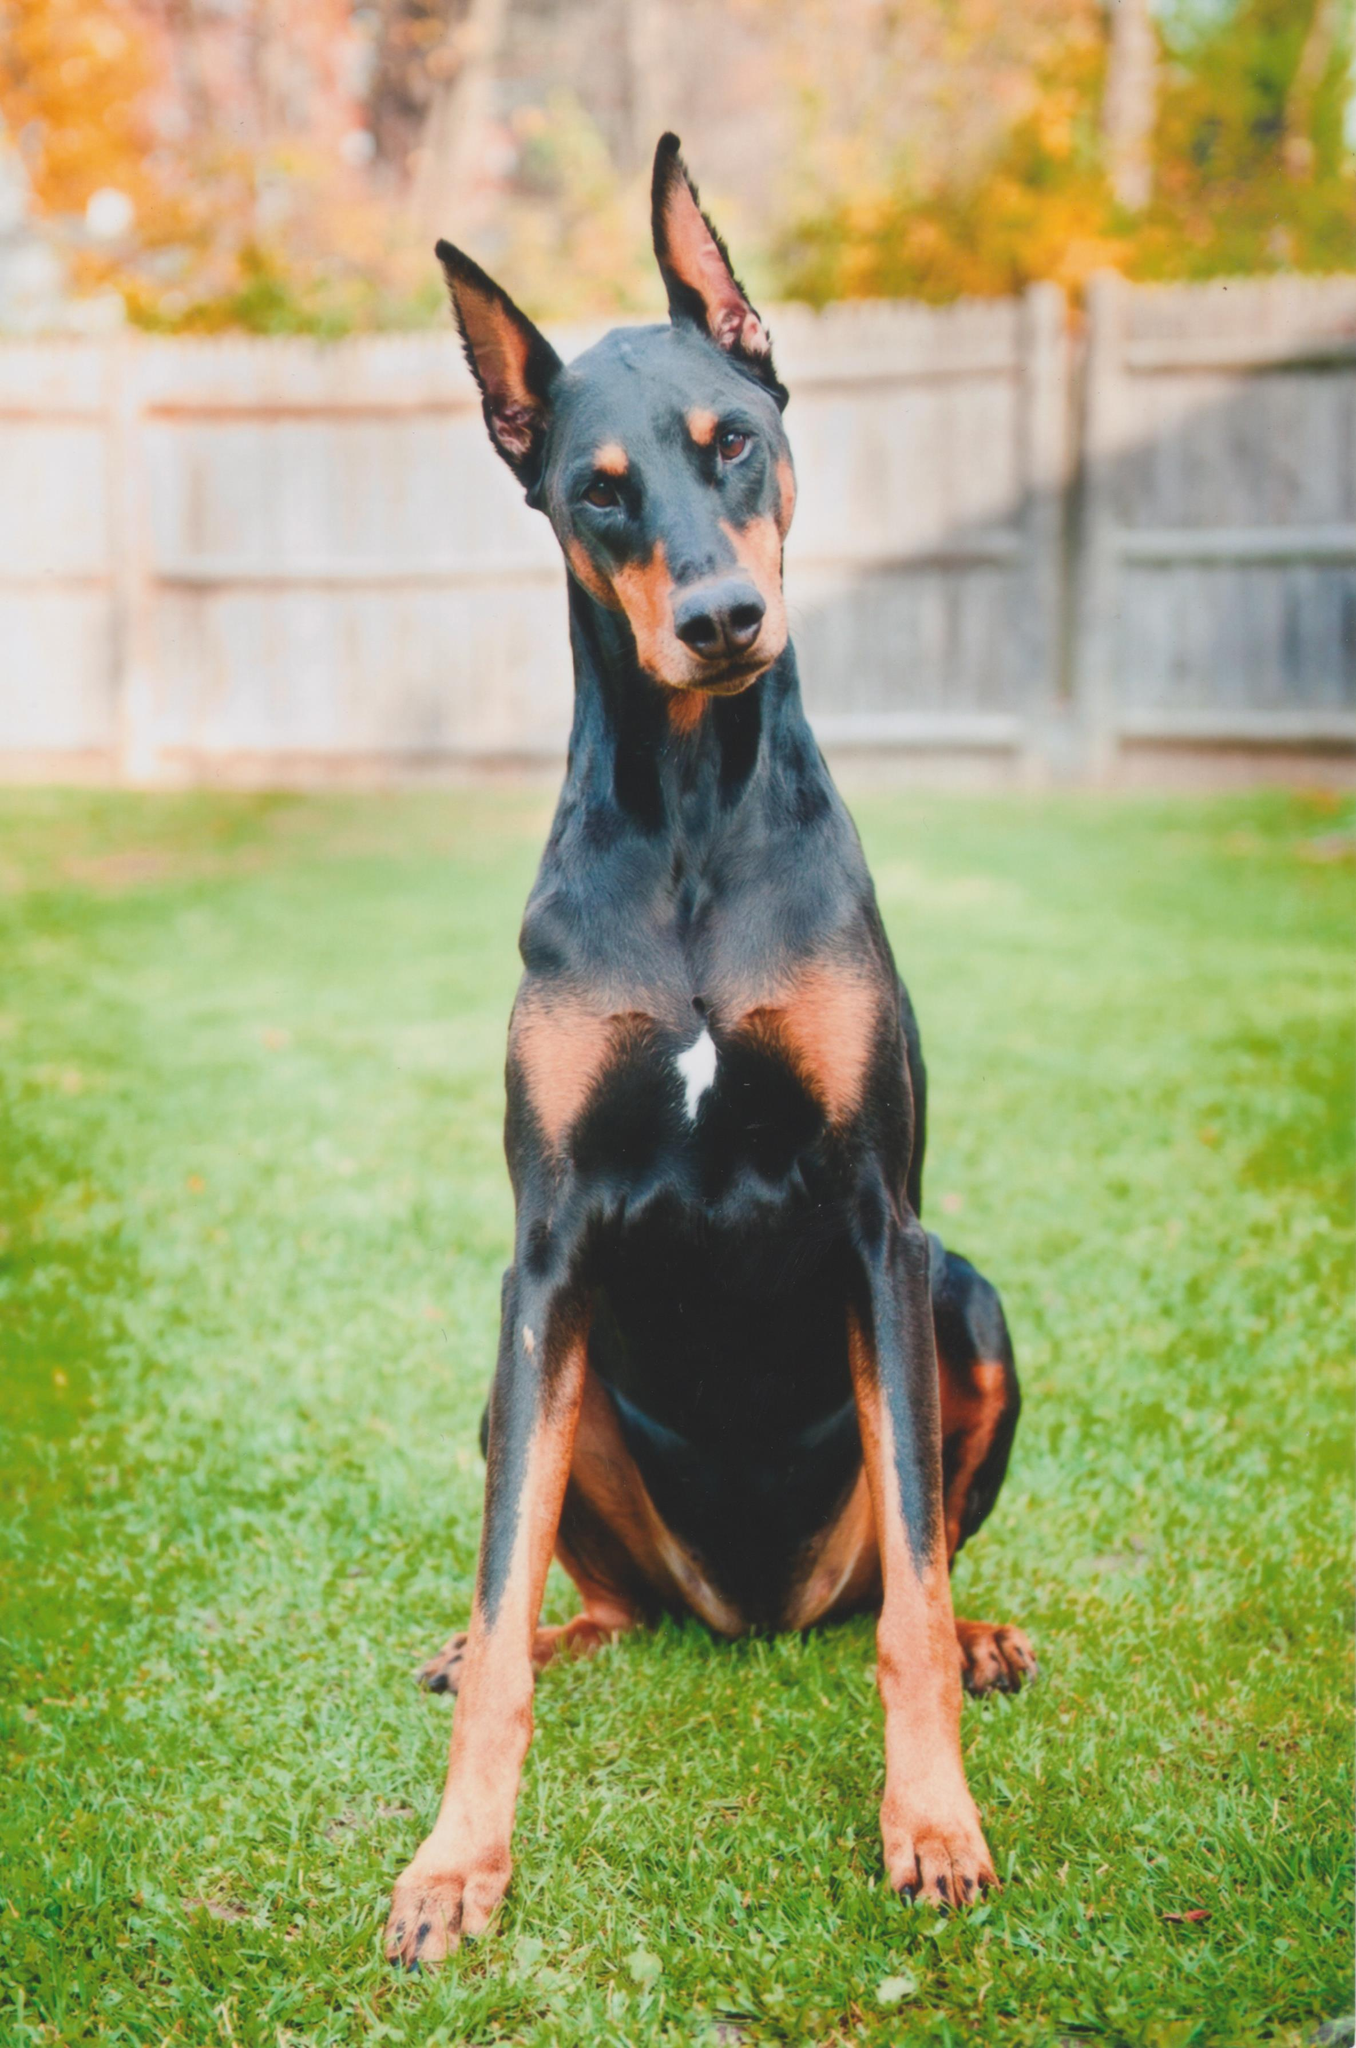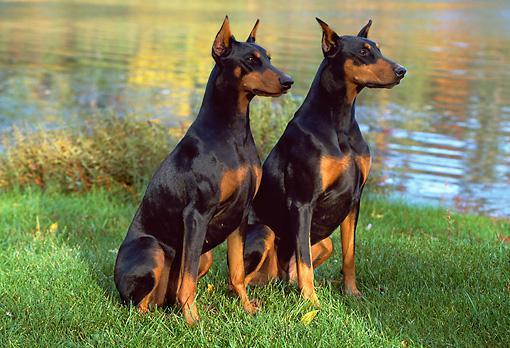The first image is the image on the left, the second image is the image on the right. Analyze the images presented: Is the assertion "A total of three pointy-eared black-and-tan dobermans are shown, with at least one staring directly at the camera, and at least one gazing rightward." valid? Answer yes or no. Yes. The first image is the image on the left, the second image is the image on the right. Considering the images on both sides, is "The right image contains exactly two dogs." valid? Answer yes or no. Yes. 